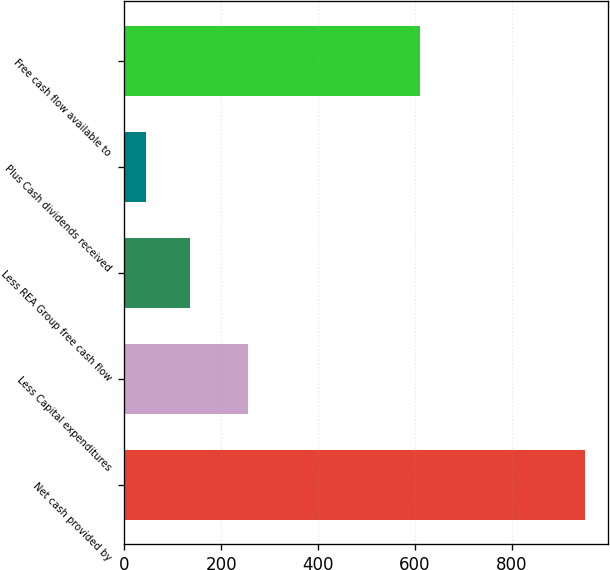Convert chart to OTSL. <chart><loc_0><loc_0><loc_500><loc_500><bar_chart><fcel>Net cash provided by<fcel>Less Capital expenditures<fcel>Less REA Group free cash flow<fcel>Plus Cash dividends received<fcel>Free cash flow available to<nl><fcel>952<fcel>256<fcel>135.7<fcel>45<fcel>610<nl></chart> 